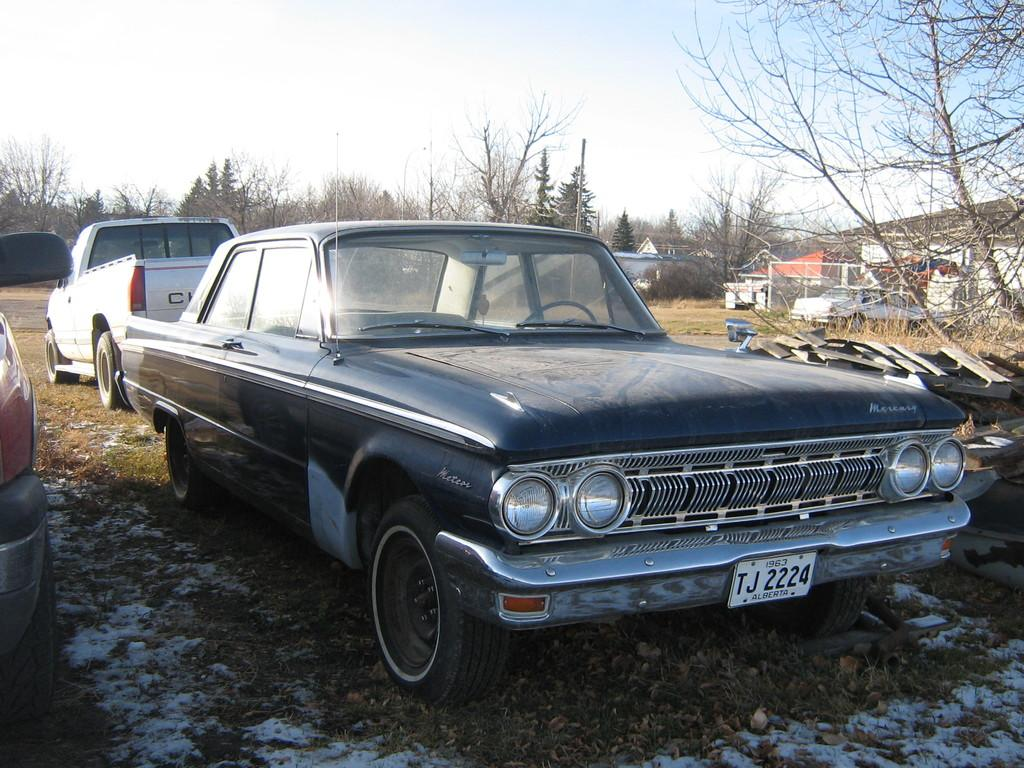How many vehicles are present in the image? There are two cars and two trucks in the image, making a total of four vehicles. What type of terrain can be seen in the image? The cars and trucks are on a grassland. What can be seen in the background of the image? There are trees and homes in the background of the image. What is visible at the top of the image? The sky is visible in the image. What sign is the expert holding while coughing in the image? There is no sign, expert, or coughing person present in the image. 